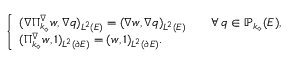Convert formula to latex. <formula><loc_0><loc_0><loc_500><loc_500>\left \{ \begin{array} { l l } { ( \nabla \Pi _ { k _ { \diamond } } ^ { \nabla } w , \nabla q ) _ { L ^ { 2 } ( E ) } = ( \nabla w , \nabla q ) _ { L ^ { 2 } ( E ) } \quad \forall \, q \in \mathbb { P } _ { k _ { \diamond } } ( E ) , } \\ { ( \Pi _ { k _ { \diamond } } ^ { \nabla } w , 1 ) _ { L ^ { 2 } ( \partial E ) } = ( w , 1 ) _ { L ^ { 2 } ( \partial E ) } . } \end{array}</formula> 